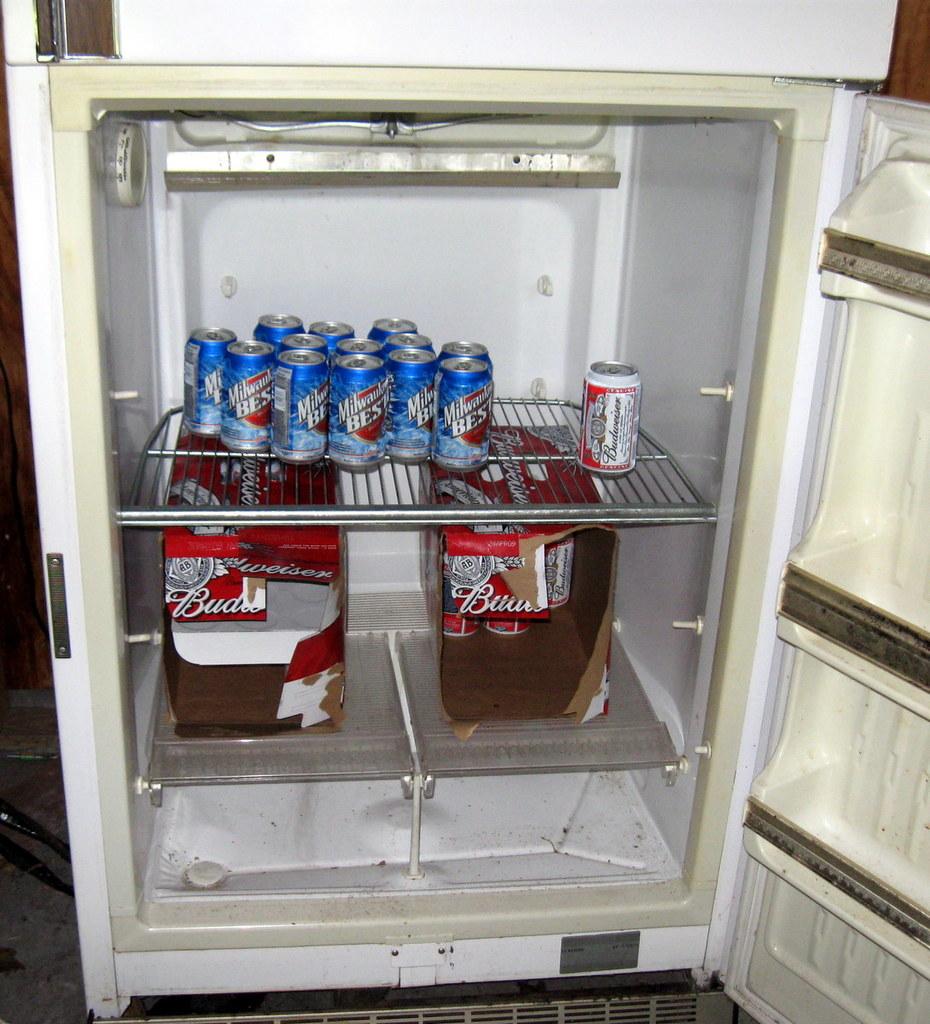What brand of beer is in the fridge?
Provide a succinct answer. Milwaukee's best. What is the brand of the beer on the top?
Keep it short and to the point. Milwaukee's best. 